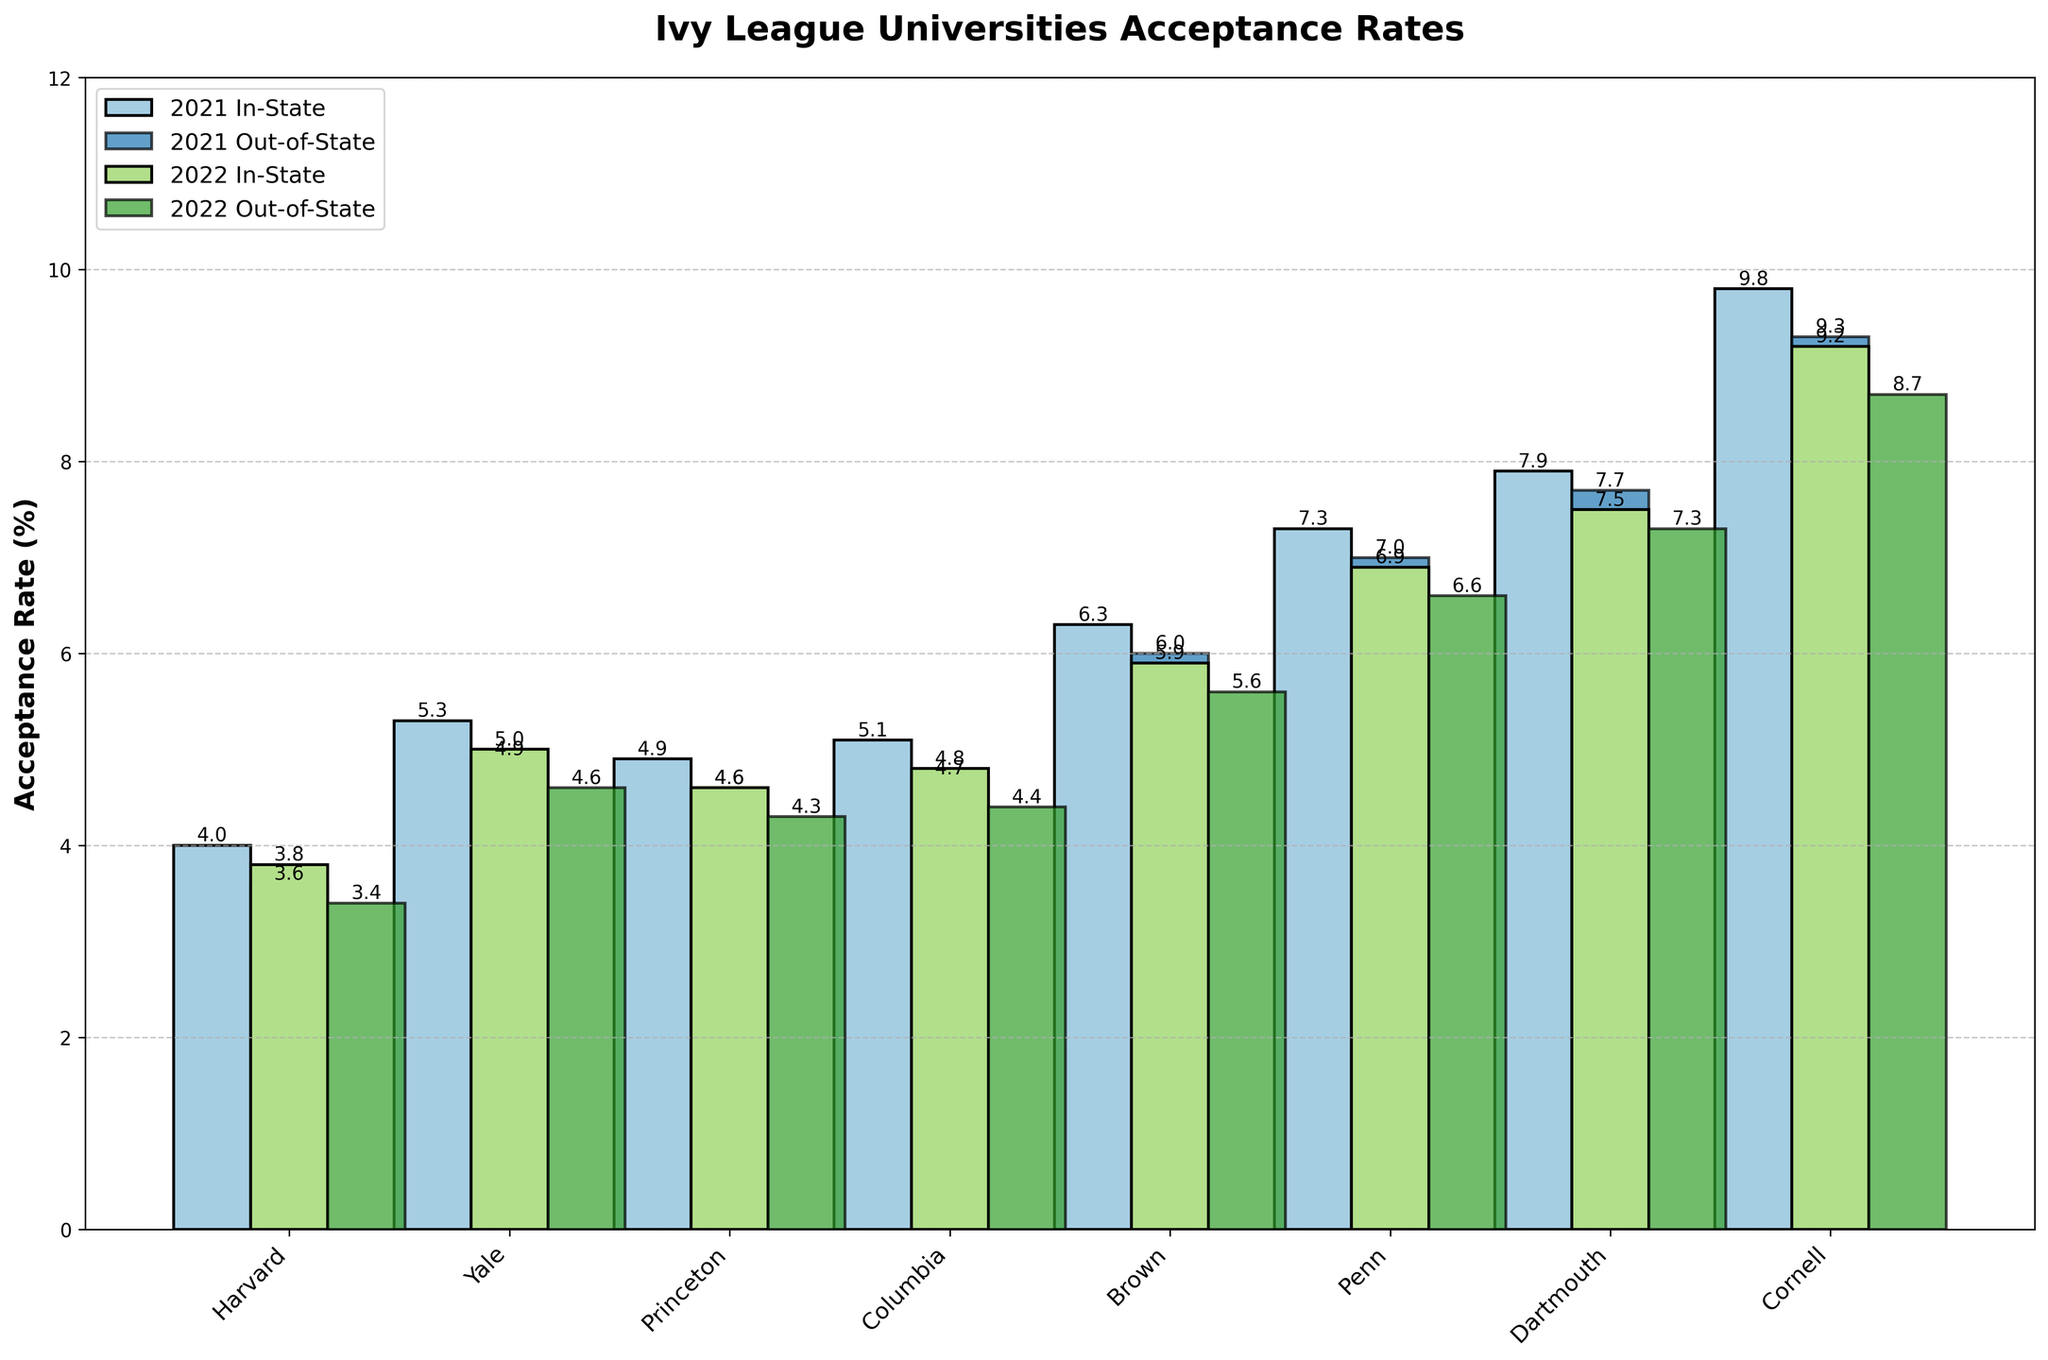What is the acceptance rate difference between in-state and out-of-state students for Harvard in 2022? To find the difference, subtract the out-of-state acceptance rate from the in-state acceptance rate for Harvard in 2022. That is 3.8 (in-state) - 3.4 (out-of-state) = 0.4
Answer: 0.4 Which university had the highest out-of-state acceptance rate in 2021? To answer this, identify the highest out-of-state acceptance rate from the visual bars for 2021 and determine the corresponding university. Looking at the plot, Dartmouth has the highest out-of-state acceptance rate in 2021 with 7.7%.
Answer: Dartmouth What was the average in-state acceptance rate for Brown and Penn in 2018? The in-state acceptance rates for Brown and Penn in 2018 are 7.4 and 8.5, respectively. The average is calculated as (7.4 + 8.5) / 2 = 7.95
Answer: 7.95 Between 2021 and 2022, did Yale's in-state acceptance rate increase or decrease? Compare the in-state acceptance rates of Yale for 2021 and 2022. In 2021, it was 5.3, and in 2022, it was 5.0. Since 5.0 < 5.3, it decreased.
Answer: Decrease Which university shows the largest difference between in-state and out-of-state acceptance rates in 2019? Identify the university by finding the largest numerical difference between in-state and out-of-state acceptance rates in 2019. The largest difference is for Harvard with a difference of 4.9 (in-state) - 4.5 (out-of-state) = 0.4.
Answer: Harvard How much did the out-of-state acceptance rate change for Columbia from 2021 to 2022? Compare the out-of-state acceptance rates for Columbia in 2021 and 2022. In 2021, it was 4.7, and in 2022, it was 4.4. The change is 4.7 - 4.4 = 0.3
Answer: 0.3 In 2020, did more universities have higher in-state acceptance rates or higher out-of-state acceptance rates? Count the universities where the in-state acceptance rates are higher and those where out-of-state acceptance rates are higher for 2020. In 2020, Harvard (4.6 vs. 4.2) and Yale (5.9 vs. 5.5), Princeton (5.4 vs. 5.1), Columbia (5.7 vs. 5.3), Brown (7.0 vs. 6.7), Penn (8.1 vs. 7.8), Dartmouth (8.5 vs. 8.3), and Cornell (10.9 vs. 10.4). All universities have higher in-state rates.
Answer: In-state acceptance rates What is the combined in-state acceptance rate for Dartmouth and Cornell in 2022? Add up the in-state acceptance rates for Dartmouth and Cornell in 2022. For Dartmouth, it is 7.5, and for Cornell, it is 9.2. So, the combined rate is 7.5 + 9.2 = 16.7
Answer: 16.7 Out of all the universities, who experienced the lowest out-of-state acceptance rate in 2022? Identify the university with the smallest out-of-state acceptance rate value in 2022 from the visual graph. Harvard had the lowest with 3.4%.
Answer: Harvard 